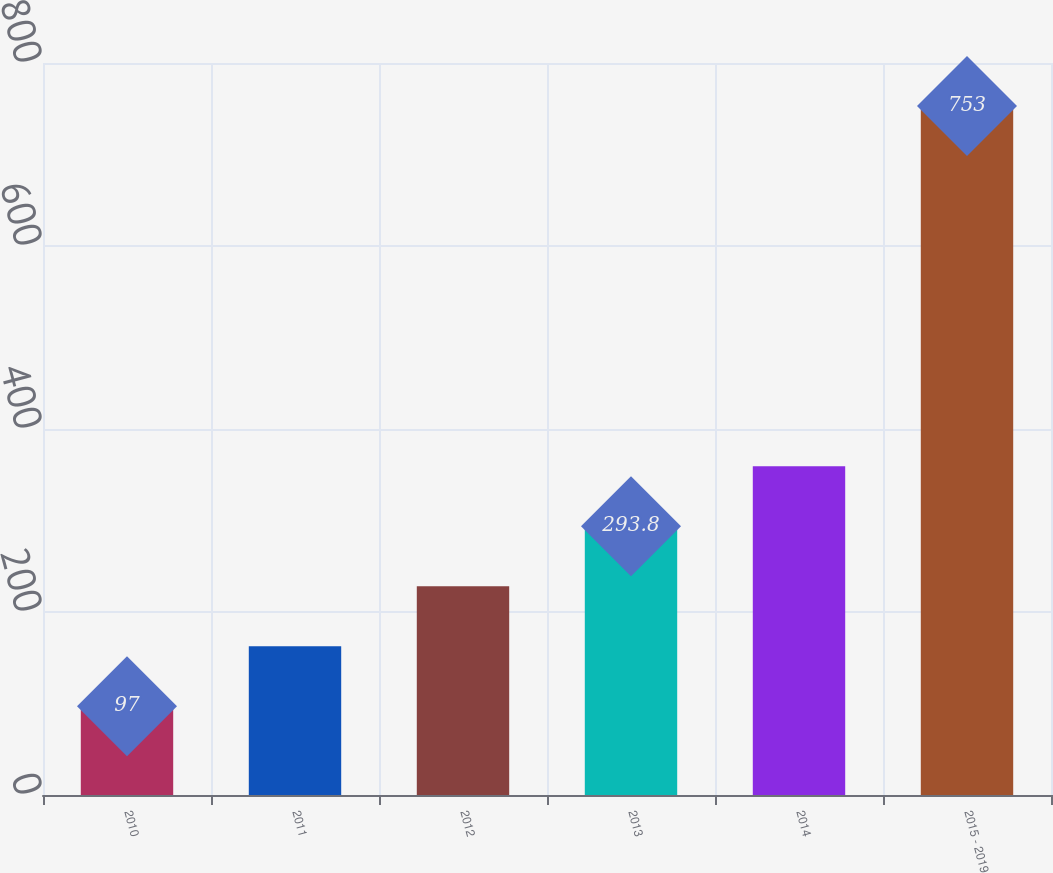Convert chart to OTSL. <chart><loc_0><loc_0><loc_500><loc_500><bar_chart><fcel>2010<fcel>2011<fcel>2012<fcel>2013<fcel>2014<fcel>2015 - 2019<nl><fcel>97<fcel>162.6<fcel>228.2<fcel>293.8<fcel>359.4<fcel>753<nl></chart> 